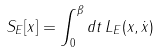<formula> <loc_0><loc_0><loc_500><loc_500>S _ { E } [ x ] = \int _ { 0 } ^ { \beta } d t \, L _ { E } ( x , \dot { x } )</formula> 